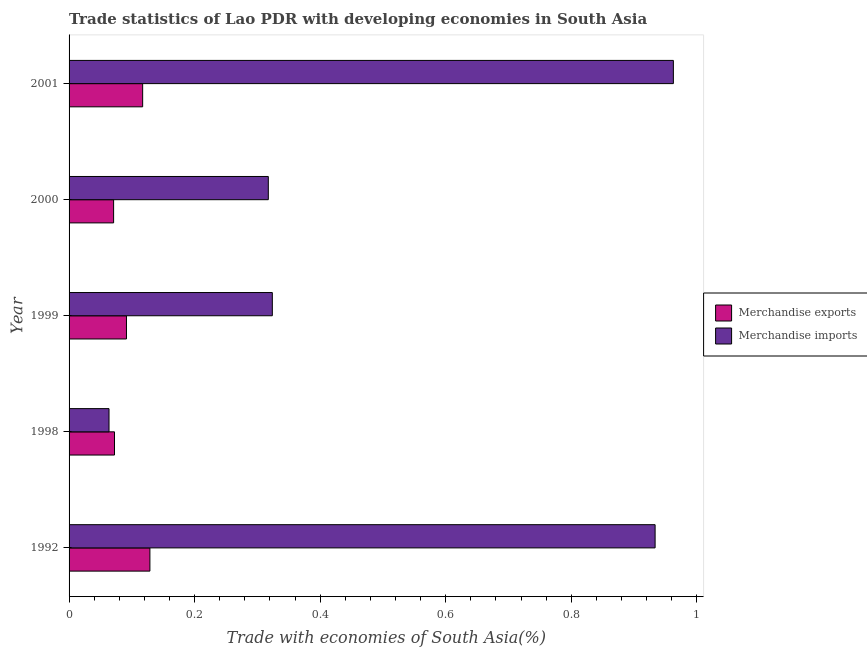How many different coloured bars are there?
Offer a very short reply. 2. How many bars are there on the 1st tick from the top?
Provide a short and direct response. 2. How many bars are there on the 4th tick from the bottom?
Provide a succinct answer. 2. In how many cases, is the number of bars for a given year not equal to the number of legend labels?
Your answer should be compact. 0. What is the merchandise imports in 2000?
Keep it short and to the point. 0.32. Across all years, what is the maximum merchandise exports?
Offer a very short reply. 0.13. Across all years, what is the minimum merchandise imports?
Your response must be concise. 0.06. In which year was the merchandise imports maximum?
Give a very brief answer. 2001. In which year was the merchandise exports minimum?
Provide a short and direct response. 2000. What is the total merchandise imports in the graph?
Your answer should be very brief. 2.6. What is the difference between the merchandise imports in 1999 and that in 2001?
Ensure brevity in your answer.  -0.64. What is the difference between the merchandise imports in 1999 and the merchandise exports in 2000?
Make the answer very short. 0.25. What is the average merchandise exports per year?
Make the answer very short. 0.1. In the year 1992, what is the difference between the merchandise imports and merchandise exports?
Keep it short and to the point. 0.81. In how many years, is the merchandise imports greater than 0.04 %?
Make the answer very short. 5. Is the difference between the merchandise exports in 2000 and 2001 greater than the difference between the merchandise imports in 2000 and 2001?
Offer a terse response. Yes. What is the difference between the highest and the second highest merchandise exports?
Offer a terse response. 0.01. In how many years, is the merchandise imports greater than the average merchandise imports taken over all years?
Provide a succinct answer. 2. Is the sum of the merchandise exports in 1992 and 1998 greater than the maximum merchandise imports across all years?
Your answer should be compact. No. What does the 1st bar from the bottom in 1999 represents?
Provide a succinct answer. Merchandise exports. How many bars are there?
Offer a very short reply. 10. Are all the bars in the graph horizontal?
Offer a terse response. Yes. How many years are there in the graph?
Provide a short and direct response. 5. What is the difference between two consecutive major ticks on the X-axis?
Provide a short and direct response. 0.2. Does the graph contain grids?
Your answer should be compact. No. How many legend labels are there?
Provide a succinct answer. 2. What is the title of the graph?
Your response must be concise. Trade statistics of Lao PDR with developing economies in South Asia. What is the label or title of the X-axis?
Give a very brief answer. Trade with economies of South Asia(%). What is the label or title of the Y-axis?
Offer a very short reply. Year. What is the Trade with economies of South Asia(%) in Merchandise exports in 1992?
Your answer should be compact. 0.13. What is the Trade with economies of South Asia(%) in Merchandise imports in 1992?
Offer a very short reply. 0.93. What is the Trade with economies of South Asia(%) of Merchandise exports in 1998?
Make the answer very short. 0.07. What is the Trade with economies of South Asia(%) of Merchandise imports in 1998?
Keep it short and to the point. 0.06. What is the Trade with economies of South Asia(%) in Merchandise exports in 1999?
Ensure brevity in your answer.  0.09. What is the Trade with economies of South Asia(%) of Merchandise imports in 1999?
Give a very brief answer. 0.32. What is the Trade with economies of South Asia(%) of Merchandise exports in 2000?
Offer a very short reply. 0.07. What is the Trade with economies of South Asia(%) in Merchandise imports in 2000?
Make the answer very short. 0.32. What is the Trade with economies of South Asia(%) in Merchandise exports in 2001?
Your answer should be compact. 0.12. What is the Trade with economies of South Asia(%) of Merchandise imports in 2001?
Ensure brevity in your answer.  0.96. Across all years, what is the maximum Trade with economies of South Asia(%) in Merchandise exports?
Offer a very short reply. 0.13. Across all years, what is the maximum Trade with economies of South Asia(%) in Merchandise imports?
Make the answer very short. 0.96. Across all years, what is the minimum Trade with economies of South Asia(%) of Merchandise exports?
Offer a terse response. 0.07. Across all years, what is the minimum Trade with economies of South Asia(%) of Merchandise imports?
Ensure brevity in your answer.  0.06. What is the total Trade with economies of South Asia(%) of Merchandise exports in the graph?
Make the answer very short. 0.48. What is the total Trade with economies of South Asia(%) in Merchandise imports in the graph?
Give a very brief answer. 2.6. What is the difference between the Trade with economies of South Asia(%) in Merchandise exports in 1992 and that in 1998?
Provide a succinct answer. 0.06. What is the difference between the Trade with economies of South Asia(%) in Merchandise imports in 1992 and that in 1998?
Your answer should be very brief. 0.87. What is the difference between the Trade with economies of South Asia(%) in Merchandise exports in 1992 and that in 1999?
Ensure brevity in your answer.  0.04. What is the difference between the Trade with economies of South Asia(%) in Merchandise imports in 1992 and that in 1999?
Provide a short and direct response. 0.61. What is the difference between the Trade with economies of South Asia(%) of Merchandise exports in 1992 and that in 2000?
Offer a terse response. 0.06. What is the difference between the Trade with economies of South Asia(%) in Merchandise imports in 1992 and that in 2000?
Ensure brevity in your answer.  0.62. What is the difference between the Trade with economies of South Asia(%) of Merchandise exports in 1992 and that in 2001?
Give a very brief answer. 0.01. What is the difference between the Trade with economies of South Asia(%) of Merchandise imports in 1992 and that in 2001?
Offer a terse response. -0.03. What is the difference between the Trade with economies of South Asia(%) in Merchandise exports in 1998 and that in 1999?
Offer a very short reply. -0.02. What is the difference between the Trade with economies of South Asia(%) in Merchandise imports in 1998 and that in 1999?
Offer a terse response. -0.26. What is the difference between the Trade with economies of South Asia(%) of Merchandise exports in 1998 and that in 2000?
Offer a terse response. 0. What is the difference between the Trade with economies of South Asia(%) of Merchandise imports in 1998 and that in 2000?
Your answer should be very brief. -0.25. What is the difference between the Trade with economies of South Asia(%) in Merchandise exports in 1998 and that in 2001?
Your response must be concise. -0.04. What is the difference between the Trade with economies of South Asia(%) of Merchandise imports in 1998 and that in 2001?
Provide a succinct answer. -0.9. What is the difference between the Trade with economies of South Asia(%) of Merchandise exports in 1999 and that in 2000?
Provide a succinct answer. 0.02. What is the difference between the Trade with economies of South Asia(%) in Merchandise imports in 1999 and that in 2000?
Your answer should be compact. 0.01. What is the difference between the Trade with economies of South Asia(%) of Merchandise exports in 1999 and that in 2001?
Your answer should be very brief. -0.03. What is the difference between the Trade with economies of South Asia(%) of Merchandise imports in 1999 and that in 2001?
Offer a terse response. -0.64. What is the difference between the Trade with economies of South Asia(%) in Merchandise exports in 2000 and that in 2001?
Your answer should be compact. -0.05. What is the difference between the Trade with economies of South Asia(%) of Merchandise imports in 2000 and that in 2001?
Offer a terse response. -0.65. What is the difference between the Trade with economies of South Asia(%) in Merchandise exports in 1992 and the Trade with economies of South Asia(%) in Merchandise imports in 1998?
Your answer should be very brief. 0.07. What is the difference between the Trade with economies of South Asia(%) of Merchandise exports in 1992 and the Trade with economies of South Asia(%) of Merchandise imports in 1999?
Your answer should be compact. -0.2. What is the difference between the Trade with economies of South Asia(%) in Merchandise exports in 1992 and the Trade with economies of South Asia(%) in Merchandise imports in 2000?
Your answer should be very brief. -0.19. What is the difference between the Trade with economies of South Asia(%) of Merchandise exports in 1992 and the Trade with economies of South Asia(%) of Merchandise imports in 2001?
Make the answer very short. -0.83. What is the difference between the Trade with economies of South Asia(%) in Merchandise exports in 1998 and the Trade with economies of South Asia(%) in Merchandise imports in 1999?
Offer a very short reply. -0.25. What is the difference between the Trade with economies of South Asia(%) in Merchandise exports in 1998 and the Trade with economies of South Asia(%) in Merchandise imports in 2000?
Your answer should be very brief. -0.24. What is the difference between the Trade with economies of South Asia(%) of Merchandise exports in 1998 and the Trade with economies of South Asia(%) of Merchandise imports in 2001?
Offer a very short reply. -0.89. What is the difference between the Trade with economies of South Asia(%) in Merchandise exports in 1999 and the Trade with economies of South Asia(%) in Merchandise imports in 2000?
Ensure brevity in your answer.  -0.23. What is the difference between the Trade with economies of South Asia(%) of Merchandise exports in 1999 and the Trade with economies of South Asia(%) of Merchandise imports in 2001?
Your answer should be very brief. -0.87. What is the difference between the Trade with economies of South Asia(%) of Merchandise exports in 2000 and the Trade with economies of South Asia(%) of Merchandise imports in 2001?
Your answer should be compact. -0.89. What is the average Trade with economies of South Asia(%) of Merchandise exports per year?
Make the answer very short. 0.1. What is the average Trade with economies of South Asia(%) of Merchandise imports per year?
Offer a very short reply. 0.52. In the year 1992, what is the difference between the Trade with economies of South Asia(%) of Merchandise exports and Trade with economies of South Asia(%) of Merchandise imports?
Provide a short and direct response. -0.8. In the year 1998, what is the difference between the Trade with economies of South Asia(%) in Merchandise exports and Trade with economies of South Asia(%) in Merchandise imports?
Keep it short and to the point. 0.01. In the year 1999, what is the difference between the Trade with economies of South Asia(%) in Merchandise exports and Trade with economies of South Asia(%) in Merchandise imports?
Your answer should be very brief. -0.23. In the year 2000, what is the difference between the Trade with economies of South Asia(%) of Merchandise exports and Trade with economies of South Asia(%) of Merchandise imports?
Ensure brevity in your answer.  -0.25. In the year 2001, what is the difference between the Trade with economies of South Asia(%) of Merchandise exports and Trade with economies of South Asia(%) of Merchandise imports?
Your response must be concise. -0.85. What is the ratio of the Trade with economies of South Asia(%) of Merchandise exports in 1992 to that in 1998?
Offer a terse response. 1.78. What is the ratio of the Trade with economies of South Asia(%) in Merchandise imports in 1992 to that in 1998?
Make the answer very short. 14.67. What is the ratio of the Trade with economies of South Asia(%) of Merchandise exports in 1992 to that in 1999?
Keep it short and to the point. 1.41. What is the ratio of the Trade with economies of South Asia(%) in Merchandise imports in 1992 to that in 1999?
Provide a short and direct response. 2.88. What is the ratio of the Trade with economies of South Asia(%) in Merchandise exports in 1992 to that in 2000?
Offer a very short reply. 1.82. What is the ratio of the Trade with economies of South Asia(%) of Merchandise imports in 1992 to that in 2000?
Provide a succinct answer. 2.94. What is the ratio of the Trade with economies of South Asia(%) of Merchandise exports in 1992 to that in 2001?
Provide a short and direct response. 1.1. What is the ratio of the Trade with economies of South Asia(%) in Merchandise imports in 1992 to that in 2001?
Make the answer very short. 0.97. What is the ratio of the Trade with economies of South Asia(%) of Merchandise exports in 1998 to that in 1999?
Make the answer very short. 0.79. What is the ratio of the Trade with economies of South Asia(%) in Merchandise imports in 1998 to that in 1999?
Offer a terse response. 0.2. What is the ratio of the Trade with economies of South Asia(%) of Merchandise exports in 1998 to that in 2000?
Give a very brief answer. 1.02. What is the ratio of the Trade with economies of South Asia(%) of Merchandise imports in 1998 to that in 2000?
Ensure brevity in your answer.  0.2. What is the ratio of the Trade with economies of South Asia(%) of Merchandise exports in 1998 to that in 2001?
Offer a very short reply. 0.62. What is the ratio of the Trade with economies of South Asia(%) of Merchandise imports in 1998 to that in 2001?
Offer a terse response. 0.07. What is the ratio of the Trade with economies of South Asia(%) in Merchandise exports in 1999 to that in 2000?
Provide a short and direct response. 1.29. What is the ratio of the Trade with economies of South Asia(%) of Merchandise imports in 1999 to that in 2000?
Offer a terse response. 1.02. What is the ratio of the Trade with economies of South Asia(%) in Merchandise exports in 1999 to that in 2001?
Keep it short and to the point. 0.78. What is the ratio of the Trade with economies of South Asia(%) of Merchandise imports in 1999 to that in 2001?
Your response must be concise. 0.34. What is the ratio of the Trade with economies of South Asia(%) of Merchandise exports in 2000 to that in 2001?
Provide a short and direct response. 0.61. What is the ratio of the Trade with economies of South Asia(%) of Merchandise imports in 2000 to that in 2001?
Ensure brevity in your answer.  0.33. What is the difference between the highest and the second highest Trade with economies of South Asia(%) in Merchandise exports?
Your answer should be very brief. 0.01. What is the difference between the highest and the second highest Trade with economies of South Asia(%) in Merchandise imports?
Provide a succinct answer. 0.03. What is the difference between the highest and the lowest Trade with economies of South Asia(%) of Merchandise exports?
Keep it short and to the point. 0.06. What is the difference between the highest and the lowest Trade with economies of South Asia(%) of Merchandise imports?
Make the answer very short. 0.9. 